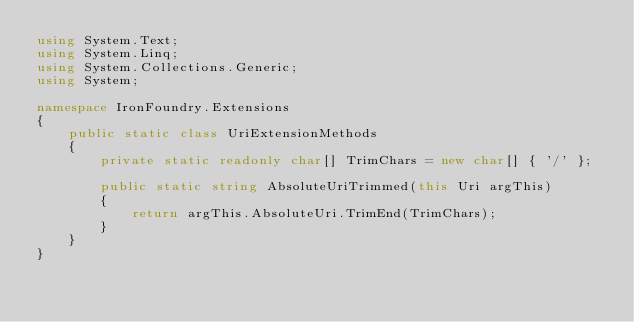<code> <loc_0><loc_0><loc_500><loc_500><_C#_>using System.Text;
using System.Linq;
using System.Collections.Generic;
using System;

namespace IronFoundry.Extensions
{
    public static class UriExtensionMethods
    {
        private static readonly char[] TrimChars = new char[] { '/' };

        public static string AbsoluteUriTrimmed(this Uri argThis)
        {
            return argThis.AbsoluteUri.TrimEnd(TrimChars);
        }
    }
}
</code> 